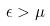<formula> <loc_0><loc_0><loc_500><loc_500>\epsilon > \mu</formula> 